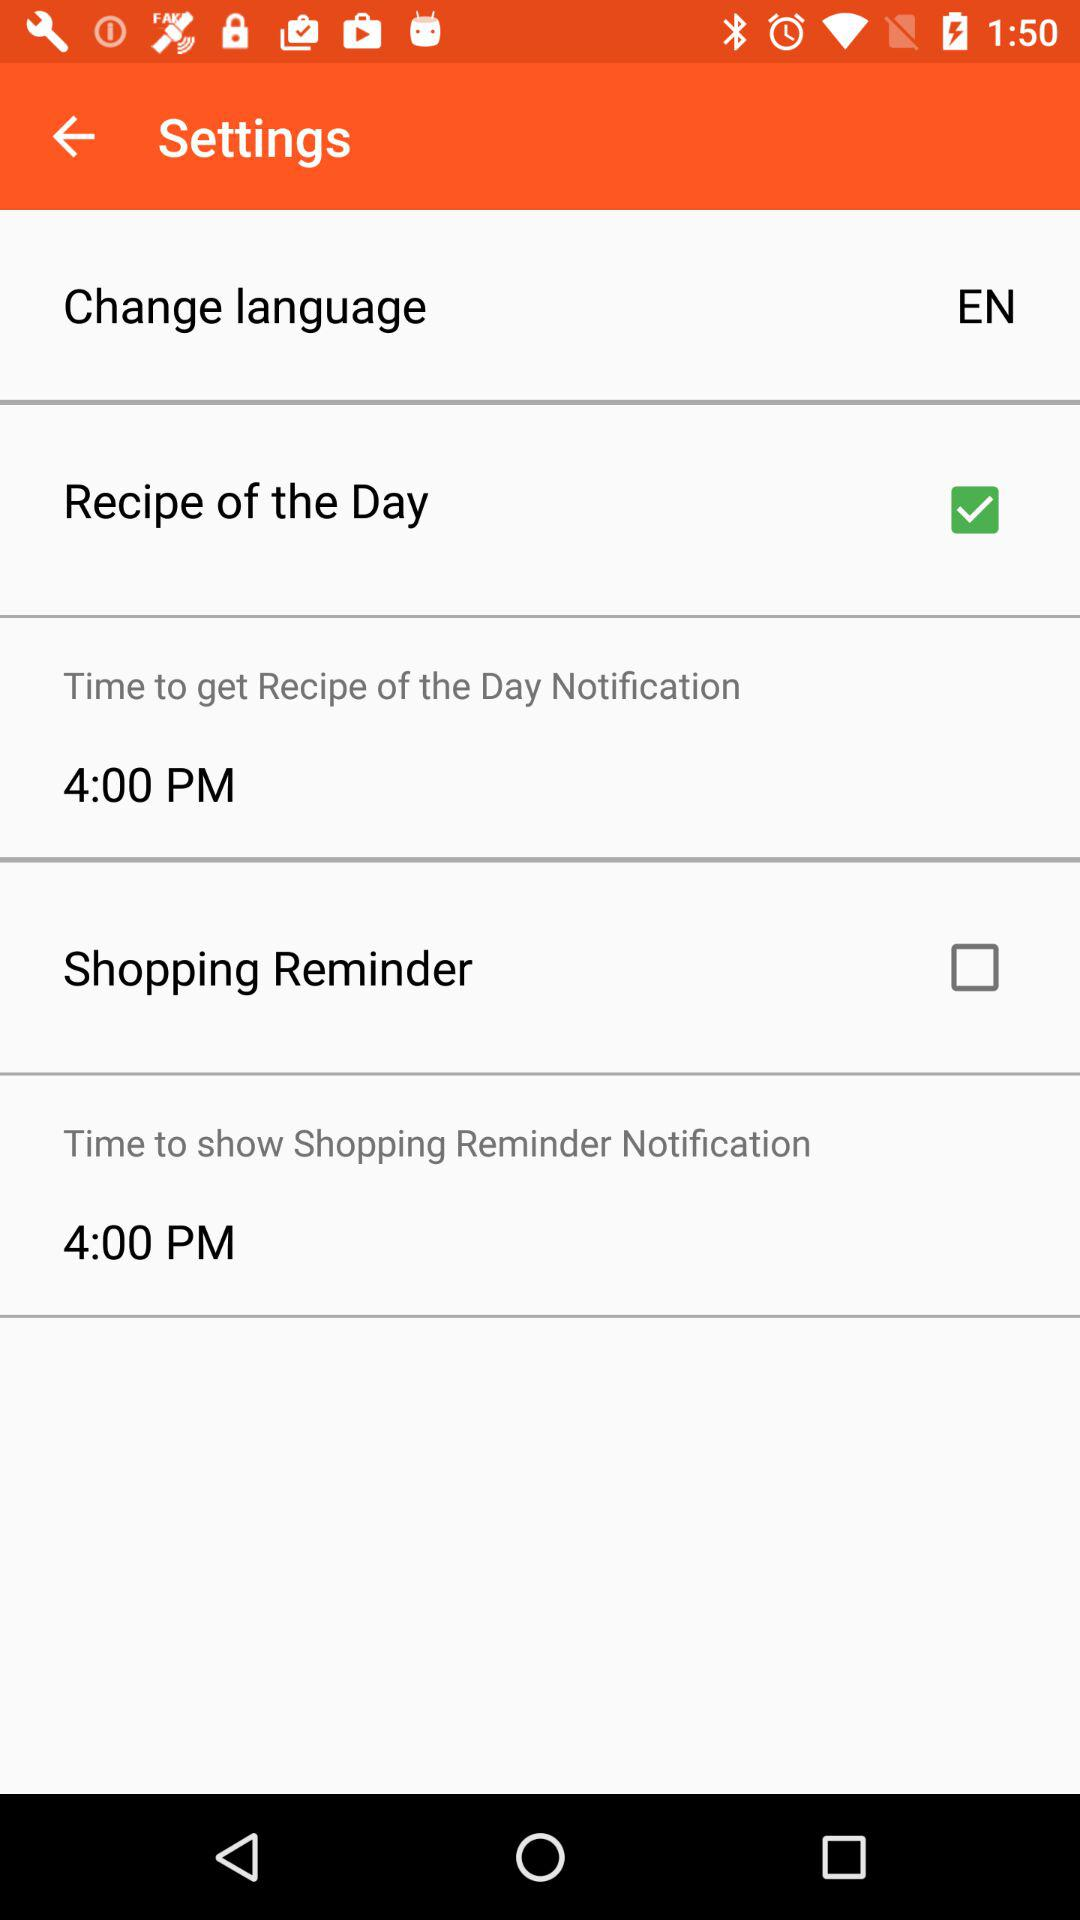What's the notification time to get the recipe? The notification time to get the recipe is 4:00 p.m. 